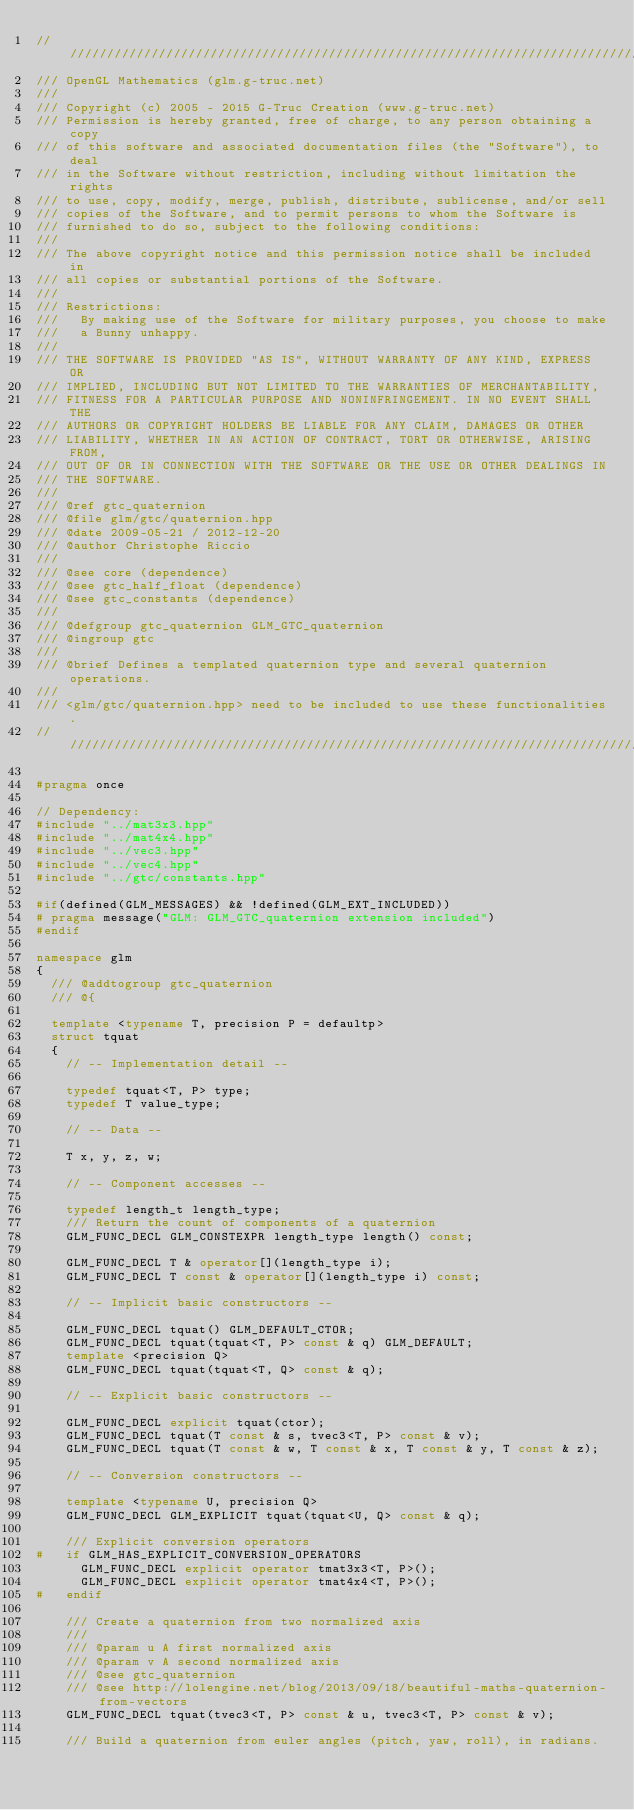Convert code to text. <code><loc_0><loc_0><loc_500><loc_500><_C++_>///////////////////////////////////////////////////////////////////////////////////
/// OpenGL Mathematics (glm.g-truc.net)
///
/// Copyright (c) 2005 - 2015 G-Truc Creation (www.g-truc.net)
/// Permission is hereby granted, free of charge, to any person obtaining a copy
/// of this software and associated documentation files (the "Software"), to deal
/// in the Software without restriction, including without limitation the rights
/// to use, copy, modify, merge, publish, distribute, sublicense, and/or sell
/// copies of the Software, and to permit persons to whom the Software is
/// furnished to do so, subject to the following conditions:
/// 
/// The above copyright notice and this permission notice shall be included in
/// all copies or substantial portions of the Software.
/// 
/// Restrictions:
///		By making use of the Software for military purposes, you choose to make
///		a Bunny unhappy.
/// 
/// THE SOFTWARE IS PROVIDED "AS IS", WITHOUT WARRANTY OF ANY KIND, EXPRESS OR
/// IMPLIED, INCLUDING BUT NOT LIMITED TO THE WARRANTIES OF MERCHANTABILITY,
/// FITNESS FOR A PARTICULAR PURPOSE AND NONINFRINGEMENT. IN NO EVENT SHALL THE
/// AUTHORS OR COPYRIGHT HOLDERS BE LIABLE FOR ANY CLAIM, DAMAGES OR OTHER
/// LIABILITY, WHETHER IN AN ACTION OF CONTRACT, TORT OR OTHERWISE, ARISING FROM,
/// OUT OF OR IN CONNECTION WITH THE SOFTWARE OR THE USE OR OTHER DEALINGS IN
/// THE SOFTWARE.
///
/// @ref gtc_quaternion
/// @file glm/gtc/quaternion.hpp
/// @date 2009-05-21 / 2012-12-20
/// @author Christophe Riccio
///
/// @see core (dependence)
/// @see gtc_half_float (dependence)
/// @see gtc_constants (dependence)
///
/// @defgroup gtc_quaternion GLM_GTC_quaternion
/// @ingroup gtc
/// 
/// @brief Defines a templated quaternion type and several quaternion operations.
/// 
/// <glm/gtc/quaternion.hpp> need to be included to use these functionalities.
///////////////////////////////////////////////////////////////////////////////////

#pragma once

// Dependency:
#include "../mat3x3.hpp"
#include "../mat4x4.hpp"
#include "../vec3.hpp"
#include "../vec4.hpp"
#include "../gtc/constants.hpp"

#if(defined(GLM_MESSAGES) && !defined(GLM_EXT_INCLUDED))
#	pragma message("GLM: GLM_GTC_quaternion extension included")
#endif

namespace glm
{
	/// @addtogroup gtc_quaternion
	/// @{

	template <typename T, precision P = defaultp>
	struct tquat
	{
		// -- Implementation detail --

		typedef tquat<T, P> type;
		typedef T value_type;

		// -- Data --

		T x, y, z, w;

		// -- Component accesses --

		typedef length_t length_type;
		/// Return the count of components of a quaternion
		GLM_FUNC_DECL GLM_CONSTEXPR length_type length() const;

		GLM_FUNC_DECL T & operator[](length_type i);
		GLM_FUNC_DECL T const & operator[](length_type i) const;

		// -- Implicit basic constructors --

		GLM_FUNC_DECL tquat() GLM_DEFAULT_CTOR;
		GLM_FUNC_DECL tquat(tquat<T, P> const & q) GLM_DEFAULT;
		template <precision Q>
		GLM_FUNC_DECL tquat(tquat<T, Q> const & q);

		// -- Explicit basic constructors --

		GLM_FUNC_DECL explicit tquat(ctor);
		GLM_FUNC_DECL tquat(T const & s, tvec3<T, P> const & v);
		GLM_FUNC_DECL tquat(T const & w, T const & x, T const & y, T const & z);

		// -- Conversion constructors --

		template <typename U, precision Q>
		GLM_FUNC_DECL GLM_EXPLICIT tquat(tquat<U, Q> const & q);

		/// Explicit conversion operators
#		if GLM_HAS_EXPLICIT_CONVERSION_OPERATORS
			GLM_FUNC_DECL explicit operator tmat3x3<T, P>();
			GLM_FUNC_DECL explicit operator tmat4x4<T, P>();
#		endif

		/// Create a quaternion from two normalized axis
		///
		/// @param u A first normalized axis
		/// @param v A second normalized axis
		/// @see gtc_quaternion
		/// @see http://lolengine.net/blog/2013/09/18/beautiful-maths-quaternion-from-vectors
		GLM_FUNC_DECL tquat(tvec3<T, P> const & u, tvec3<T, P> const & v);

		/// Build a quaternion from euler angles (pitch, yaw, roll), in radians.</code> 